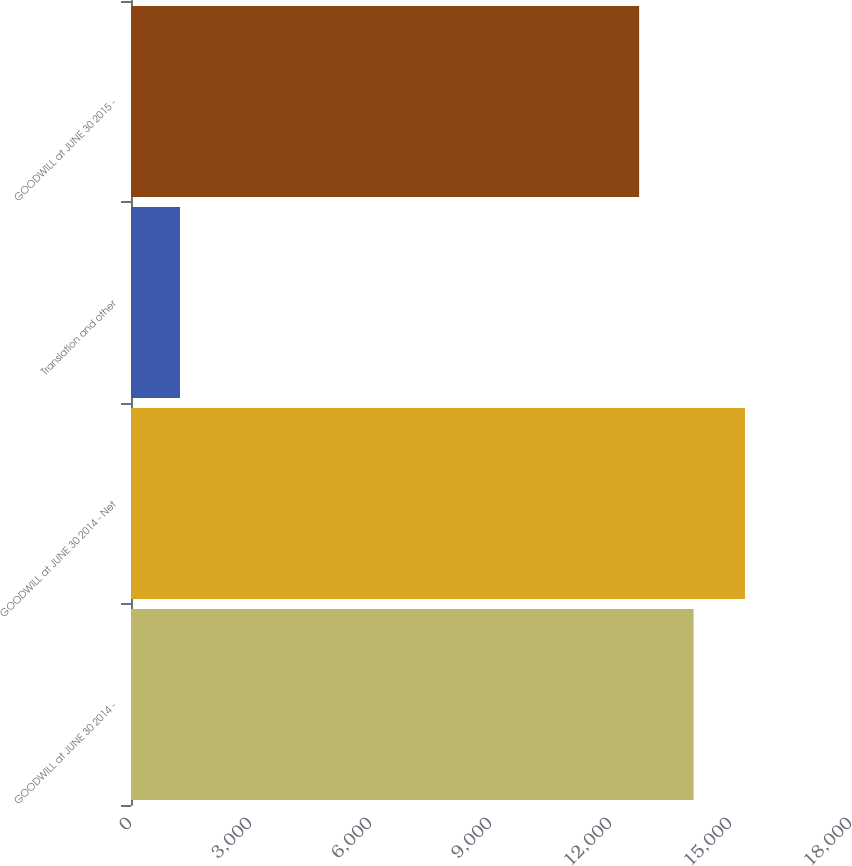Convert chart. <chart><loc_0><loc_0><loc_500><loc_500><bar_chart><fcel>GOODWILL at JUNE 30 2014 -<fcel>GOODWILL at JUNE 30 2014 - Net<fcel>Translation and other<fcel>GOODWILL at JUNE 30 2015 -<nl><fcel>14065<fcel>15349<fcel>1225<fcel>12704<nl></chart> 